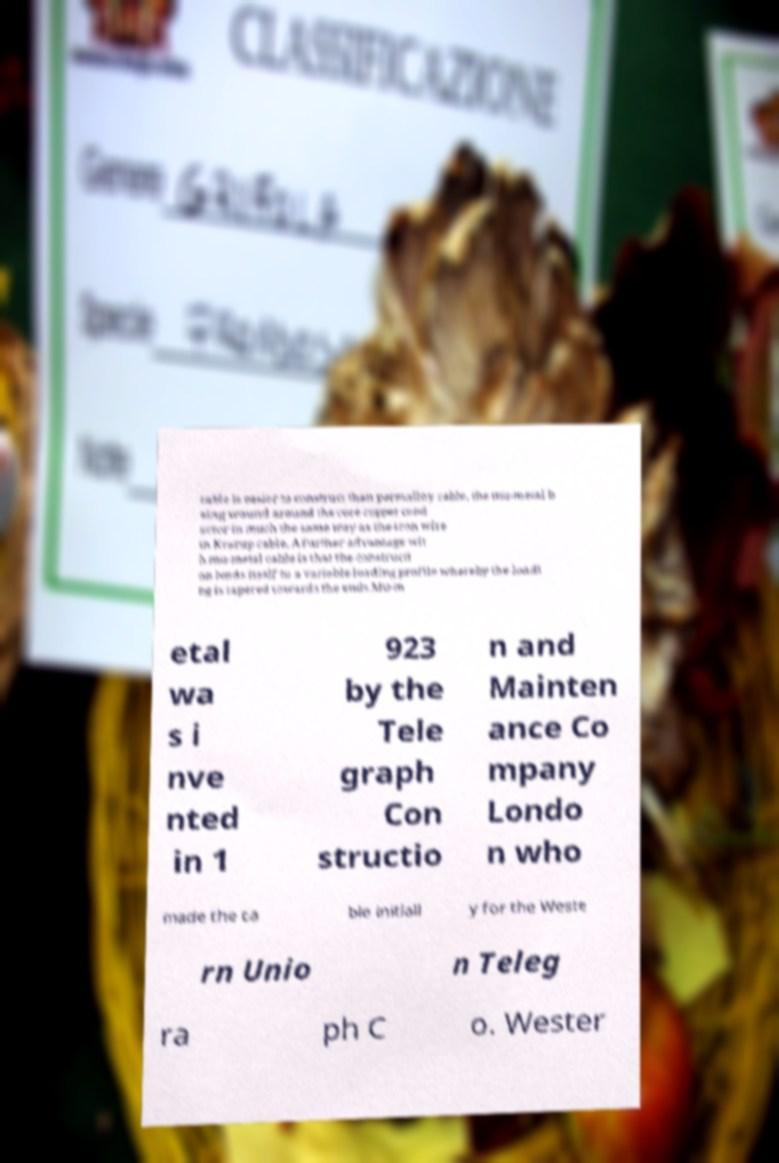What messages or text are displayed in this image? I need them in a readable, typed format. cable is easier to construct than permalloy cable, the mu-metal b eing wound around the core copper cond uctor in much the same way as the iron wire in Krarup cable. A further advantage wit h mu-metal cable is that the constructi on lends itself to a variable loading profile whereby the loadi ng is tapered towards the ends.Mu-m etal wa s i nve nted in 1 923 by the Tele graph Con structio n and Mainten ance Co mpany Londo n who made the ca ble initiall y for the Weste rn Unio n Teleg ra ph C o. Wester 